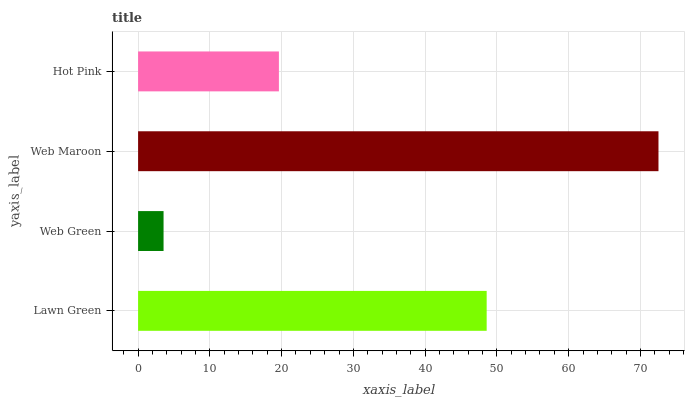Is Web Green the minimum?
Answer yes or no. Yes. Is Web Maroon the maximum?
Answer yes or no. Yes. Is Web Maroon the minimum?
Answer yes or no. No. Is Web Green the maximum?
Answer yes or no. No. Is Web Maroon greater than Web Green?
Answer yes or no. Yes. Is Web Green less than Web Maroon?
Answer yes or no. Yes. Is Web Green greater than Web Maroon?
Answer yes or no. No. Is Web Maroon less than Web Green?
Answer yes or no. No. Is Lawn Green the high median?
Answer yes or no. Yes. Is Hot Pink the low median?
Answer yes or no. Yes. Is Hot Pink the high median?
Answer yes or no. No. Is Lawn Green the low median?
Answer yes or no. No. 